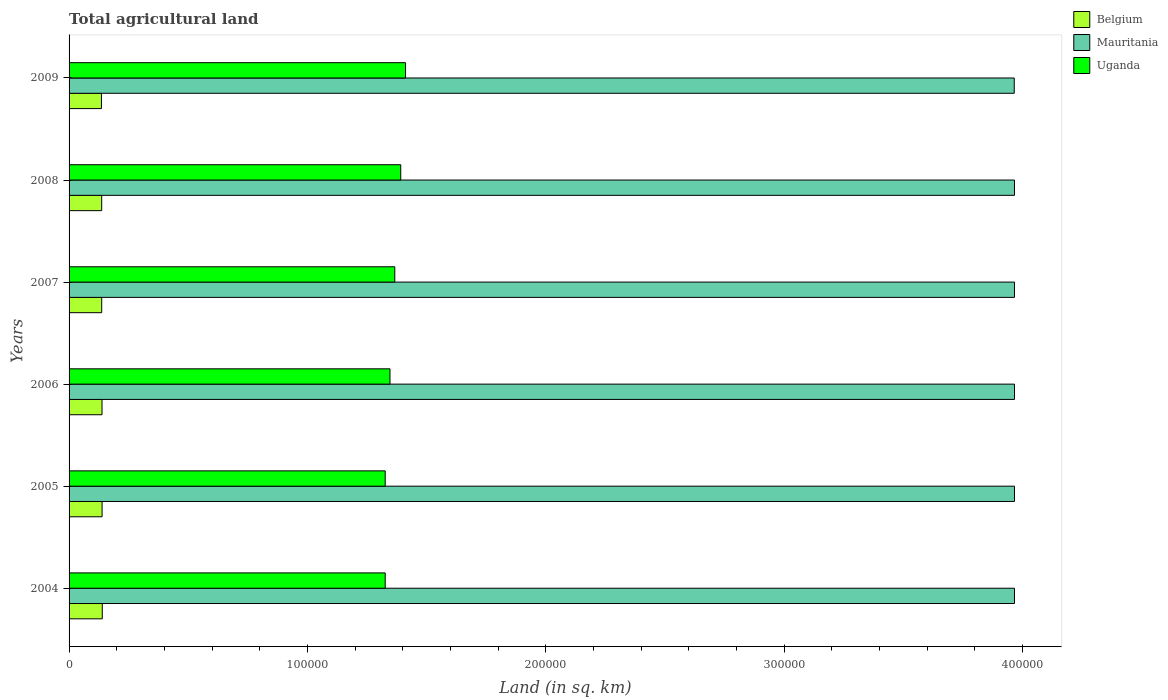How many different coloured bars are there?
Keep it short and to the point. 3. Are the number of bars on each tick of the Y-axis equal?
Offer a terse response. Yes. How many bars are there on the 4th tick from the top?
Ensure brevity in your answer.  3. How many bars are there on the 6th tick from the bottom?
Ensure brevity in your answer.  3. In how many cases, is the number of bars for a given year not equal to the number of legend labels?
Make the answer very short. 0. What is the total agricultural land in Mauritania in 2006?
Give a very brief answer. 3.97e+05. Across all years, what is the maximum total agricultural land in Mauritania?
Give a very brief answer. 3.97e+05. Across all years, what is the minimum total agricultural land in Uganda?
Keep it short and to the point. 1.33e+05. In which year was the total agricultural land in Mauritania minimum?
Provide a short and direct response. 2009. What is the total total agricultural land in Mauritania in the graph?
Give a very brief answer. 2.38e+06. What is the difference between the total agricultural land in Mauritania in 2006 and the total agricultural land in Uganda in 2009?
Give a very brief answer. 2.55e+05. What is the average total agricultural land in Belgium per year?
Provide a succinct answer. 1.38e+04. In the year 2009, what is the difference between the total agricultural land in Mauritania and total agricultural land in Belgium?
Provide a short and direct response. 3.83e+05. Is the total agricultural land in Mauritania in 2004 less than that in 2006?
Provide a short and direct response. No. What is the difference between the highest and the second highest total agricultural land in Belgium?
Your response must be concise. 80. What is the difference between the highest and the lowest total agricultural land in Belgium?
Your answer should be very brief. 350. What does the 1st bar from the top in 2004 represents?
Provide a succinct answer. Uganda. What does the 3rd bar from the bottom in 2005 represents?
Give a very brief answer. Uganda. How many bars are there?
Your response must be concise. 18. Are all the bars in the graph horizontal?
Offer a terse response. Yes. How many years are there in the graph?
Offer a very short reply. 6. How many legend labels are there?
Ensure brevity in your answer.  3. What is the title of the graph?
Keep it short and to the point. Total agricultural land. What is the label or title of the X-axis?
Give a very brief answer. Land (in sq. km). What is the label or title of the Y-axis?
Keep it short and to the point. Years. What is the Land (in sq. km) of Belgium in 2004?
Offer a terse response. 1.39e+04. What is the Land (in sq. km) in Mauritania in 2004?
Provide a succinct answer. 3.97e+05. What is the Land (in sq. km) in Uganda in 2004?
Offer a terse response. 1.33e+05. What is the Land (in sq. km) in Belgium in 2005?
Make the answer very short. 1.38e+04. What is the Land (in sq. km) in Mauritania in 2005?
Give a very brief answer. 3.97e+05. What is the Land (in sq. km) of Uganda in 2005?
Your answer should be very brief. 1.33e+05. What is the Land (in sq. km) of Belgium in 2006?
Your answer should be compact. 1.38e+04. What is the Land (in sq. km) of Mauritania in 2006?
Offer a terse response. 3.97e+05. What is the Land (in sq. km) in Uganda in 2006?
Your answer should be very brief. 1.35e+05. What is the Land (in sq. km) of Belgium in 2007?
Your answer should be compact. 1.37e+04. What is the Land (in sq. km) of Mauritania in 2007?
Your answer should be very brief. 3.97e+05. What is the Land (in sq. km) in Uganda in 2007?
Ensure brevity in your answer.  1.37e+05. What is the Land (in sq. km) in Belgium in 2008?
Ensure brevity in your answer.  1.37e+04. What is the Land (in sq. km) of Mauritania in 2008?
Your response must be concise. 3.97e+05. What is the Land (in sq. km) in Uganda in 2008?
Keep it short and to the point. 1.39e+05. What is the Land (in sq. km) of Belgium in 2009?
Your answer should be compact. 1.36e+04. What is the Land (in sq. km) in Mauritania in 2009?
Make the answer very short. 3.97e+05. What is the Land (in sq. km) of Uganda in 2009?
Your answer should be very brief. 1.41e+05. Across all years, what is the maximum Land (in sq. km) of Belgium?
Your response must be concise. 1.39e+04. Across all years, what is the maximum Land (in sq. km) in Mauritania?
Offer a terse response. 3.97e+05. Across all years, what is the maximum Land (in sq. km) of Uganda?
Offer a very short reply. 1.41e+05. Across all years, what is the minimum Land (in sq. km) in Belgium?
Ensure brevity in your answer.  1.36e+04. Across all years, what is the minimum Land (in sq. km) of Mauritania?
Ensure brevity in your answer.  3.97e+05. Across all years, what is the minimum Land (in sq. km) in Uganda?
Provide a short and direct response. 1.33e+05. What is the total Land (in sq. km) in Belgium in the graph?
Your answer should be very brief. 8.26e+04. What is the total Land (in sq. km) of Mauritania in the graph?
Provide a succinct answer. 2.38e+06. What is the total Land (in sq. km) of Uganda in the graph?
Your response must be concise. 8.17e+05. What is the difference between the Land (in sq. km) in Mauritania in 2004 and that in 2005?
Provide a short and direct response. 0. What is the difference between the Land (in sq. km) of Belgium in 2004 and that in 2006?
Your response must be concise. 110. What is the difference between the Land (in sq. km) in Uganda in 2004 and that in 2006?
Give a very brief answer. -2007.5. What is the difference between the Land (in sq. km) of Belgium in 2004 and that in 2007?
Your response must be concise. 240. What is the difference between the Land (in sq. km) of Mauritania in 2004 and that in 2007?
Provide a short and direct response. 0. What is the difference between the Land (in sq. km) of Uganda in 2004 and that in 2007?
Your answer should be very brief. -4015. What is the difference between the Land (in sq. km) of Belgium in 2004 and that in 2008?
Your answer should be compact. 250. What is the difference between the Land (in sq. km) of Mauritania in 2004 and that in 2008?
Offer a very short reply. 0. What is the difference between the Land (in sq. km) in Uganda in 2004 and that in 2008?
Offer a terse response. -6522.5. What is the difference between the Land (in sq. km) of Belgium in 2004 and that in 2009?
Provide a succinct answer. 350. What is the difference between the Land (in sq. km) in Mauritania in 2004 and that in 2009?
Give a very brief answer. 100. What is the difference between the Land (in sq. km) in Uganda in 2004 and that in 2009?
Provide a succinct answer. -8530. What is the difference between the Land (in sq. km) of Belgium in 2005 and that in 2006?
Make the answer very short. 30. What is the difference between the Land (in sq. km) in Uganda in 2005 and that in 2006?
Your response must be concise. -2007.5. What is the difference between the Land (in sq. km) of Belgium in 2005 and that in 2007?
Keep it short and to the point. 160. What is the difference between the Land (in sq. km) of Mauritania in 2005 and that in 2007?
Offer a terse response. 0. What is the difference between the Land (in sq. km) of Uganda in 2005 and that in 2007?
Your answer should be very brief. -4015. What is the difference between the Land (in sq. km) of Belgium in 2005 and that in 2008?
Your answer should be very brief. 170. What is the difference between the Land (in sq. km) in Mauritania in 2005 and that in 2008?
Keep it short and to the point. 0. What is the difference between the Land (in sq. km) in Uganda in 2005 and that in 2008?
Offer a terse response. -6522.5. What is the difference between the Land (in sq. km) of Belgium in 2005 and that in 2009?
Provide a succinct answer. 270. What is the difference between the Land (in sq. km) of Uganda in 2005 and that in 2009?
Provide a short and direct response. -8530. What is the difference between the Land (in sq. km) of Belgium in 2006 and that in 2007?
Make the answer very short. 130. What is the difference between the Land (in sq. km) in Uganda in 2006 and that in 2007?
Provide a succinct answer. -2007.5. What is the difference between the Land (in sq. km) of Belgium in 2006 and that in 2008?
Give a very brief answer. 140. What is the difference between the Land (in sq. km) of Mauritania in 2006 and that in 2008?
Ensure brevity in your answer.  0. What is the difference between the Land (in sq. km) in Uganda in 2006 and that in 2008?
Offer a very short reply. -4515. What is the difference between the Land (in sq. km) in Belgium in 2006 and that in 2009?
Ensure brevity in your answer.  240. What is the difference between the Land (in sq. km) in Mauritania in 2006 and that in 2009?
Give a very brief answer. 100. What is the difference between the Land (in sq. km) in Uganda in 2006 and that in 2009?
Provide a succinct answer. -6522.5. What is the difference between the Land (in sq. km) in Belgium in 2007 and that in 2008?
Provide a succinct answer. 10. What is the difference between the Land (in sq. km) in Mauritania in 2007 and that in 2008?
Make the answer very short. 0. What is the difference between the Land (in sq. km) of Uganda in 2007 and that in 2008?
Provide a short and direct response. -2507.5. What is the difference between the Land (in sq. km) in Belgium in 2007 and that in 2009?
Ensure brevity in your answer.  110. What is the difference between the Land (in sq. km) of Mauritania in 2007 and that in 2009?
Your response must be concise. 100. What is the difference between the Land (in sq. km) in Uganda in 2007 and that in 2009?
Ensure brevity in your answer.  -4515. What is the difference between the Land (in sq. km) in Uganda in 2008 and that in 2009?
Your answer should be compact. -2007.5. What is the difference between the Land (in sq. km) of Belgium in 2004 and the Land (in sq. km) of Mauritania in 2005?
Provide a succinct answer. -3.83e+05. What is the difference between the Land (in sq. km) of Belgium in 2004 and the Land (in sq. km) of Uganda in 2005?
Make the answer very short. -1.19e+05. What is the difference between the Land (in sq. km) in Mauritania in 2004 and the Land (in sq. km) in Uganda in 2005?
Your answer should be compact. 2.64e+05. What is the difference between the Land (in sq. km) of Belgium in 2004 and the Land (in sq. km) of Mauritania in 2006?
Offer a terse response. -3.83e+05. What is the difference between the Land (in sq. km) in Belgium in 2004 and the Land (in sq. km) in Uganda in 2006?
Keep it short and to the point. -1.21e+05. What is the difference between the Land (in sq. km) in Mauritania in 2004 and the Land (in sq. km) in Uganda in 2006?
Make the answer very short. 2.62e+05. What is the difference between the Land (in sq. km) in Belgium in 2004 and the Land (in sq. km) in Mauritania in 2007?
Make the answer very short. -3.83e+05. What is the difference between the Land (in sq. km) of Belgium in 2004 and the Land (in sq. km) of Uganda in 2007?
Your answer should be compact. -1.23e+05. What is the difference between the Land (in sq. km) in Mauritania in 2004 and the Land (in sq. km) in Uganda in 2007?
Provide a succinct answer. 2.60e+05. What is the difference between the Land (in sq. km) in Belgium in 2004 and the Land (in sq. km) in Mauritania in 2008?
Provide a short and direct response. -3.83e+05. What is the difference between the Land (in sq. km) of Belgium in 2004 and the Land (in sq. km) of Uganda in 2008?
Offer a terse response. -1.25e+05. What is the difference between the Land (in sq. km) in Mauritania in 2004 and the Land (in sq. km) in Uganda in 2008?
Your answer should be compact. 2.57e+05. What is the difference between the Land (in sq. km) of Belgium in 2004 and the Land (in sq. km) of Mauritania in 2009?
Ensure brevity in your answer.  -3.83e+05. What is the difference between the Land (in sq. km) in Belgium in 2004 and the Land (in sq. km) in Uganda in 2009?
Make the answer very short. -1.27e+05. What is the difference between the Land (in sq. km) of Mauritania in 2004 and the Land (in sq. km) of Uganda in 2009?
Make the answer very short. 2.55e+05. What is the difference between the Land (in sq. km) of Belgium in 2005 and the Land (in sq. km) of Mauritania in 2006?
Your answer should be very brief. -3.83e+05. What is the difference between the Land (in sq. km) in Belgium in 2005 and the Land (in sq. km) in Uganda in 2006?
Make the answer very short. -1.21e+05. What is the difference between the Land (in sq. km) of Mauritania in 2005 and the Land (in sq. km) of Uganda in 2006?
Make the answer very short. 2.62e+05. What is the difference between the Land (in sq. km) in Belgium in 2005 and the Land (in sq. km) in Mauritania in 2007?
Your response must be concise. -3.83e+05. What is the difference between the Land (in sq. km) of Belgium in 2005 and the Land (in sq. km) of Uganda in 2007?
Provide a short and direct response. -1.23e+05. What is the difference between the Land (in sq. km) in Mauritania in 2005 and the Land (in sq. km) in Uganda in 2007?
Make the answer very short. 2.60e+05. What is the difference between the Land (in sq. km) in Belgium in 2005 and the Land (in sq. km) in Mauritania in 2008?
Make the answer very short. -3.83e+05. What is the difference between the Land (in sq. km) of Belgium in 2005 and the Land (in sq. km) of Uganda in 2008?
Offer a terse response. -1.25e+05. What is the difference between the Land (in sq. km) of Mauritania in 2005 and the Land (in sq. km) of Uganda in 2008?
Make the answer very short. 2.57e+05. What is the difference between the Land (in sq. km) in Belgium in 2005 and the Land (in sq. km) in Mauritania in 2009?
Your answer should be compact. -3.83e+05. What is the difference between the Land (in sq. km) of Belgium in 2005 and the Land (in sq. km) of Uganda in 2009?
Provide a short and direct response. -1.27e+05. What is the difference between the Land (in sq. km) of Mauritania in 2005 and the Land (in sq. km) of Uganda in 2009?
Your answer should be compact. 2.55e+05. What is the difference between the Land (in sq. km) of Belgium in 2006 and the Land (in sq. km) of Mauritania in 2007?
Make the answer very short. -3.83e+05. What is the difference between the Land (in sq. km) in Belgium in 2006 and the Land (in sq. km) in Uganda in 2007?
Your answer should be compact. -1.23e+05. What is the difference between the Land (in sq. km) in Mauritania in 2006 and the Land (in sq. km) in Uganda in 2007?
Keep it short and to the point. 2.60e+05. What is the difference between the Land (in sq. km) of Belgium in 2006 and the Land (in sq. km) of Mauritania in 2008?
Give a very brief answer. -3.83e+05. What is the difference between the Land (in sq. km) in Belgium in 2006 and the Land (in sq. km) in Uganda in 2008?
Keep it short and to the point. -1.25e+05. What is the difference between the Land (in sq. km) in Mauritania in 2006 and the Land (in sq. km) in Uganda in 2008?
Keep it short and to the point. 2.57e+05. What is the difference between the Land (in sq. km) of Belgium in 2006 and the Land (in sq. km) of Mauritania in 2009?
Your response must be concise. -3.83e+05. What is the difference between the Land (in sq. km) of Belgium in 2006 and the Land (in sq. km) of Uganda in 2009?
Your response must be concise. -1.27e+05. What is the difference between the Land (in sq. km) in Mauritania in 2006 and the Land (in sq. km) in Uganda in 2009?
Give a very brief answer. 2.55e+05. What is the difference between the Land (in sq. km) in Belgium in 2007 and the Land (in sq. km) in Mauritania in 2008?
Your answer should be compact. -3.83e+05. What is the difference between the Land (in sq. km) of Belgium in 2007 and the Land (in sq. km) of Uganda in 2008?
Ensure brevity in your answer.  -1.25e+05. What is the difference between the Land (in sq. km) of Mauritania in 2007 and the Land (in sq. km) of Uganda in 2008?
Your answer should be very brief. 2.57e+05. What is the difference between the Land (in sq. km) in Belgium in 2007 and the Land (in sq. km) in Mauritania in 2009?
Your response must be concise. -3.83e+05. What is the difference between the Land (in sq. km) of Belgium in 2007 and the Land (in sq. km) of Uganda in 2009?
Provide a short and direct response. -1.27e+05. What is the difference between the Land (in sq. km) of Mauritania in 2007 and the Land (in sq. km) of Uganda in 2009?
Your answer should be compact. 2.55e+05. What is the difference between the Land (in sq. km) in Belgium in 2008 and the Land (in sq. km) in Mauritania in 2009?
Your answer should be very brief. -3.83e+05. What is the difference between the Land (in sq. km) of Belgium in 2008 and the Land (in sq. km) of Uganda in 2009?
Give a very brief answer. -1.27e+05. What is the difference between the Land (in sq. km) of Mauritania in 2008 and the Land (in sq. km) of Uganda in 2009?
Keep it short and to the point. 2.55e+05. What is the average Land (in sq. km) of Belgium per year?
Ensure brevity in your answer.  1.38e+04. What is the average Land (in sq. km) in Mauritania per year?
Offer a terse response. 3.97e+05. What is the average Land (in sq. km) in Uganda per year?
Ensure brevity in your answer.  1.36e+05. In the year 2004, what is the difference between the Land (in sq. km) in Belgium and Land (in sq. km) in Mauritania?
Provide a succinct answer. -3.83e+05. In the year 2004, what is the difference between the Land (in sq. km) of Belgium and Land (in sq. km) of Uganda?
Provide a succinct answer. -1.19e+05. In the year 2004, what is the difference between the Land (in sq. km) of Mauritania and Land (in sq. km) of Uganda?
Make the answer very short. 2.64e+05. In the year 2005, what is the difference between the Land (in sq. km) of Belgium and Land (in sq. km) of Mauritania?
Your response must be concise. -3.83e+05. In the year 2005, what is the difference between the Land (in sq. km) in Belgium and Land (in sq. km) in Uganda?
Your answer should be compact. -1.19e+05. In the year 2005, what is the difference between the Land (in sq. km) in Mauritania and Land (in sq. km) in Uganda?
Keep it short and to the point. 2.64e+05. In the year 2006, what is the difference between the Land (in sq. km) in Belgium and Land (in sq. km) in Mauritania?
Your answer should be compact. -3.83e+05. In the year 2006, what is the difference between the Land (in sq. km) in Belgium and Land (in sq. km) in Uganda?
Ensure brevity in your answer.  -1.21e+05. In the year 2006, what is the difference between the Land (in sq. km) of Mauritania and Land (in sq. km) of Uganda?
Your response must be concise. 2.62e+05. In the year 2007, what is the difference between the Land (in sq. km) of Belgium and Land (in sq. km) of Mauritania?
Give a very brief answer. -3.83e+05. In the year 2007, what is the difference between the Land (in sq. km) of Belgium and Land (in sq. km) of Uganda?
Your response must be concise. -1.23e+05. In the year 2007, what is the difference between the Land (in sq. km) in Mauritania and Land (in sq. km) in Uganda?
Offer a very short reply. 2.60e+05. In the year 2008, what is the difference between the Land (in sq. km) of Belgium and Land (in sq. km) of Mauritania?
Your answer should be compact. -3.83e+05. In the year 2008, what is the difference between the Land (in sq. km) in Belgium and Land (in sq. km) in Uganda?
Your answer should be very brief. -1.25e+05. In the year 2008, what is the difference between the Land (in sq. km) in Mauritania and Land (in sq. km) in Uganda?
Offer a very short reply. 2.57e+05. In the year 2009, what is the difference between the Land (in sq. km) of Belgium and Land (in sq. km) of Mauritania?
Your response must be concise. -3.83e+05. In the year 2009, what is the difference between the Land (in sq. km) in Belgium and Land (in sq. km) in Uganda?
Provide a short and direct response. -1.28e+05. In the year 2009, what is the difference between the Land (in sq. km) of Mauritania and Land (in sq. km) of Uganda?
Offer a terse response. 2.55e+05. What is the ratio of the Land (in sq. km) in Belgium in 2004 to that in 2005?
Your response must be concise. 1.01. What is the ratio of the Land (in sq. km) of Mauritania in 2004 to that in 2005?
Ensure brevity in your answer.  1. What is the ratio of the Land (in sq. km) in Uganda in 2004 to that in 2005?
Your answer should be compact. 1. What is the ratio of the Land (in sq. km) in Belgium in 2004 to that in 2006?
Ensure brevity in your answer.  1.01. What is the ratio of the Land (in sq. km) of Uganda in 2004 to that in 2006?
Your answer should be very brief. 0.99. What is the ratio of the Land (in sq. km) of Belgium in 2004 to that in 2007?
Keep it short and to the point. 1.02. What is the ratio of the Land (in sq. km) of Mauritania in 2004 to that in 2007?
Provide a succinct answer. 1. What is the ratio of the Land (in sq. km) of Uganda in 2004 to that in 2007?
Your response must be concise. 0.97. What is the ratio of the Land (in sq. km) in Belgium in 2004 to that in 2008?
Give a very brief answer. 1.02. What is the ratio of the Land (in sq. km) in Uganda in 2004 to that in 2008?
Your answer should be very brief. 0.95. What is the ratio of the Land (in sq. km) of Belgium in 2004 to that in 2009?
Your response must be concise. 1.03. What is the ratio of the Land (in sq. km) of Uganda in 2004 to that in 2009?
Your answer should be compact. 0.94. What is the ratio of the Land (in sq. km) in Uganda in 2005 to that in 2006?
Provide a succinct answer. 0.99. What is the ratio of the Land (in sq. km) in Belgium in 2005 to that in 2007?
Make the answer very short. 1.01. What is the ratio of the Land (in sq. km) in Uganda in 2005 to that in 2007?
Your response must be concise. 0.97. What is the ratio of the Land (in sq. km) in Belgium in 2005 to that in 2008?
Your answer should be very brief. 1.01. What is the ratio of the Land (in sq. km) in Uganda in 2005 to that in 2008?
Provide a short and direct response. 0.95. What is the ratio of the Land (in sq. km) of Belgium in 2005 to that in 2009?
Offer a terse response. 1.02. What is the ratio of the Land (in sq. km) of Mauritania in 2005 to that in 2009?
Offer a very short reply. 1. What is the ratio of the Land (in sq. km) in Uganda in 2005 to that in 2009?
Offer a terse response. 0.94. What is the ratio of the Land (in sq. km) in Belgium in 2006 to that in 2007?
Offer a very short reply. 1.01. What is the ratio of the Land (in sq. km) of Belgium in 2006 to that in 2008?
Your answer should be very brief. 1.01. What is the ratio of the Land (in sq. km) of Uganda in 2006 to that in 2008?
Provide a succinct answer. 0.97. What is the ratio of the Land (in sq. km) in Belgium in 2006 to that in 2009?
Provide a succinct answer. 1.02. What is the ratio of the Land (in sq. km) in Uganda in 2006 to that in 2009?
Give a very brief answer. 0.95. What is the ratio of the Land (in sq. km) in Belgium in 2007 to that in 2008?
Offer a terse response. 1. What is the ratio of the Land (in sq. km) in Uganda in 2007 to that in 2008?
Your answer should be very brief. 0.98. What is the ratio of the Land (in sq. km) in Belgium in 2007 to that in 2009?
Offer a terse response. 1.01. What is the ratio of the Land (in sq. km) in Uganda in 2007 to that in 2009?
Your response must be concise. 0.97. What is the ratio of the Land (in sq. km) in Belgium in 2008 to that in 2009?
Give a very brief answer. 1.01. What is the ratio of the Land (in sq. km) in Uganda in 2008 to that in 2009?
Provide a succinct answer. 0.99. What is the difference between the highest and the second highest Land (in sq. km) in Uganda?
Your answer should be compact. 2007.5. What is the difference between the highest and the lowest Land (in sq. km) in Belgium?
Your answer should be very brief. 350. What is the difference between the highest and the lowest Land (in sq. km) in Mauritania?
Offer a terse response. 100. What is the difference between the highest and the lowest Land (in sq. km) of Uganda?
Provide a succinct answer. 8530. 